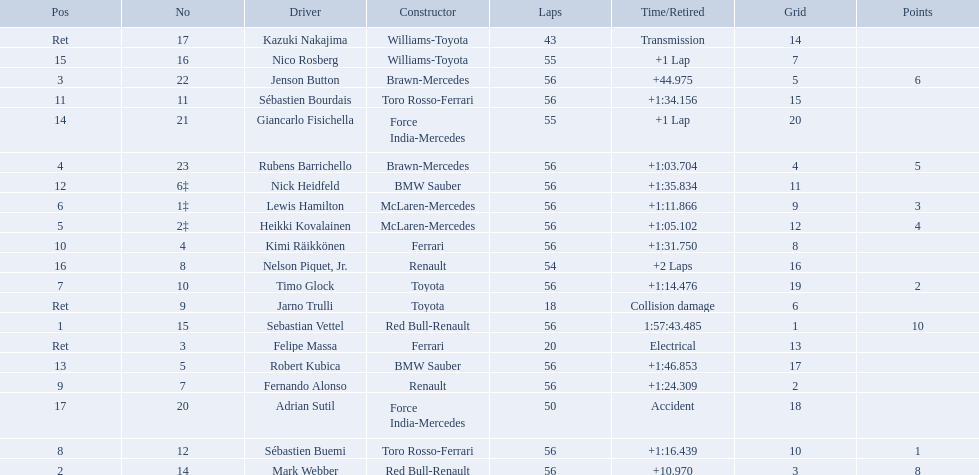Which drive retired because of electrical issues? Felipe Massa. Which driver retired due to accident? Adrian Sutil. Which driver retired due to collision damage? Jarno Trulli. 